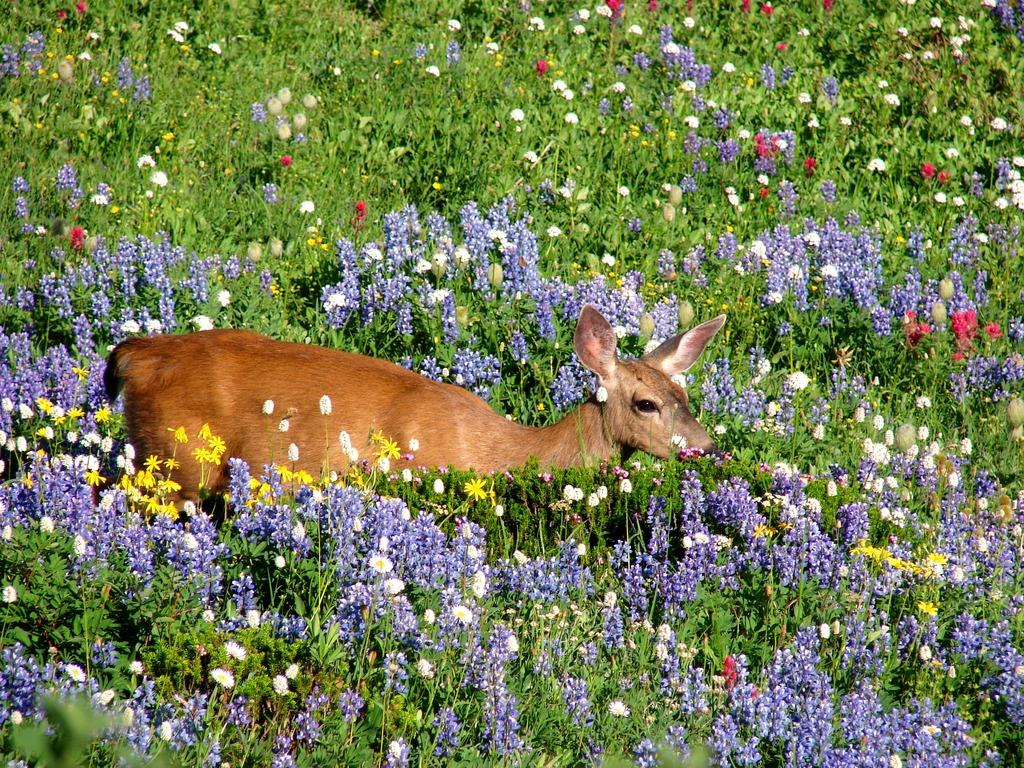What animal can be seen in the image? There is a deer in the image. Where is the deer located? The deer is standing on the ground. What types of flowers are present in the image? There are purple, red, and white flowers in the image. What color are the plants in the image? The plants are green in the image. What type of silk is being used to make the deer's coat in the image? There is no silk present in the image, and the deer's coat is not made of silk. Can you tell me how many beans are visible in the image? There are no beans present in the image. 